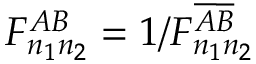Convert formula to latex. <formula><loc_0><loc_0><loc_500><loc_500>F _ { n _ { 1 } n _ { 2 } } ^ { A B } = 1 / F _ { n _ { 1 } n _ { 2 } } ^ { \overline { A } \overline { B } }</formula> 